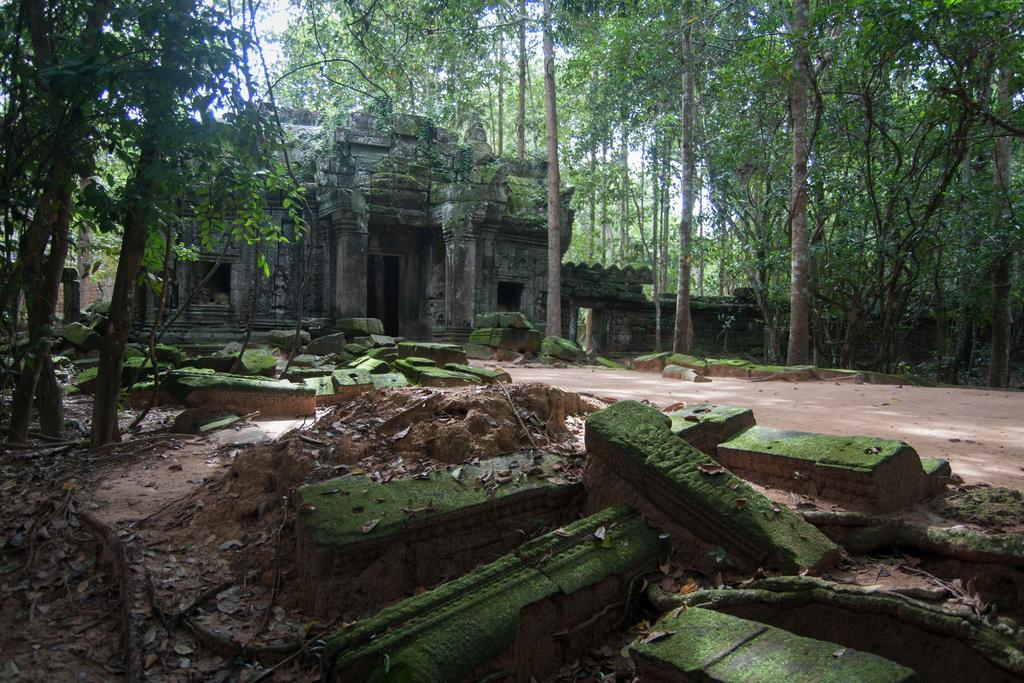What type of structure is in the image? There is a fort in the image. What can be seen in the background of the image? There are trees and rocks in the background of the image. What is visible at the bottom of the image? There is ground visible at the bottom of the image. What type of clouds can be seen in the image? There are no clouds visible in the image. How many trees are present in the image? The number of trees cannot be determined from the image, as only the presence of trees is mentioned. 